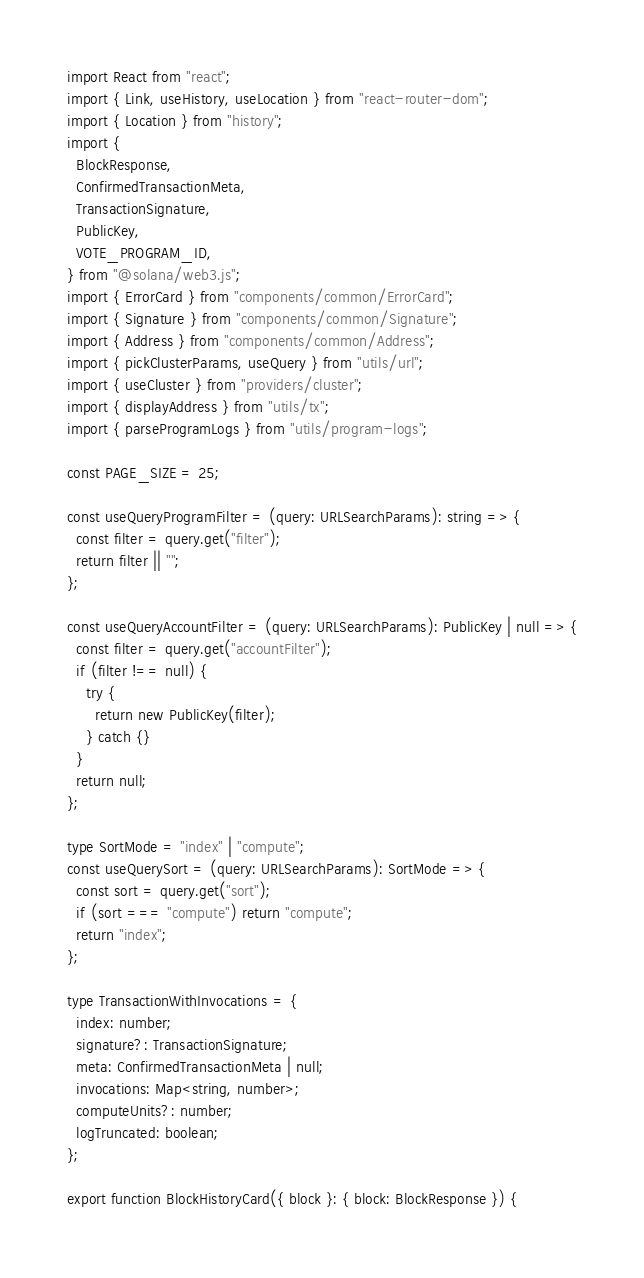<code> <loc_0><loc_0><loc_500><loc_500><_TypeScript_>import React from "react";
import { Link, useHistory, useLocation } from "react-router-dom";
import { Location } from "history";
import {
  BlockResponse,
  ConfirmedTransactionMeta,
  TransactionSignature,
  PublicKey,
  VOTE_PROGRAM_ID,
} from "@solana/web3.js";
import { ErrorCard } from "components/common/ErrorCard";
import { Signature } from "components/common/Signature";
import { Address } from "components/common/Address";
import { pickClusterParams, useQuery } from "utils/url";
import { useCluster } from "providers/cluster";
import { displayAddress } from "utils/tx";
import { parseProgramLogs } from "utils/program-logs";

const PAGE_SIZE = 25;

const useQueryProgramFilter = (query: URLSearchParams): string => {
  const filter = query.get("filter");
  return filter || "";
};

const useQueryAccountFilter = (query: URLSearchParams): PublicKey | null => {
  const filter = query.get("accountFilter");
  if (filter !== null) {
    try {
      return new PublicKey(filter);
    } catch {}
  }
  return null;
};

type SortMode = "index" | "compute";
const useQuerySort = (query: URLSearchParams): SortMode => {
  const sort = query.get("sort");
  if (sort === "compute") return "compute";
  return "index";
};

type TransactionWithInvocations = {
  index: number;
  signature?: TransactionSignature;
  meta: ConfirmedTransactionMeta | null;
  invocations: Map<string, number>;
  computeUnits?: number;
  logTruncated: boolean;
};

export function BlockHistoryCard({ block }: { block: BlockResponse }) {</code> 